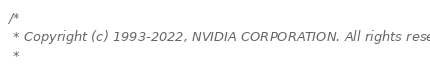Convert code to text. <code><loc_0><loc_0><loc_500><loc_500><_C_>/*
 * Copyright (c) 1993-2022, NVIDIA CORPORATION. All rights reserved.
 *</code> 